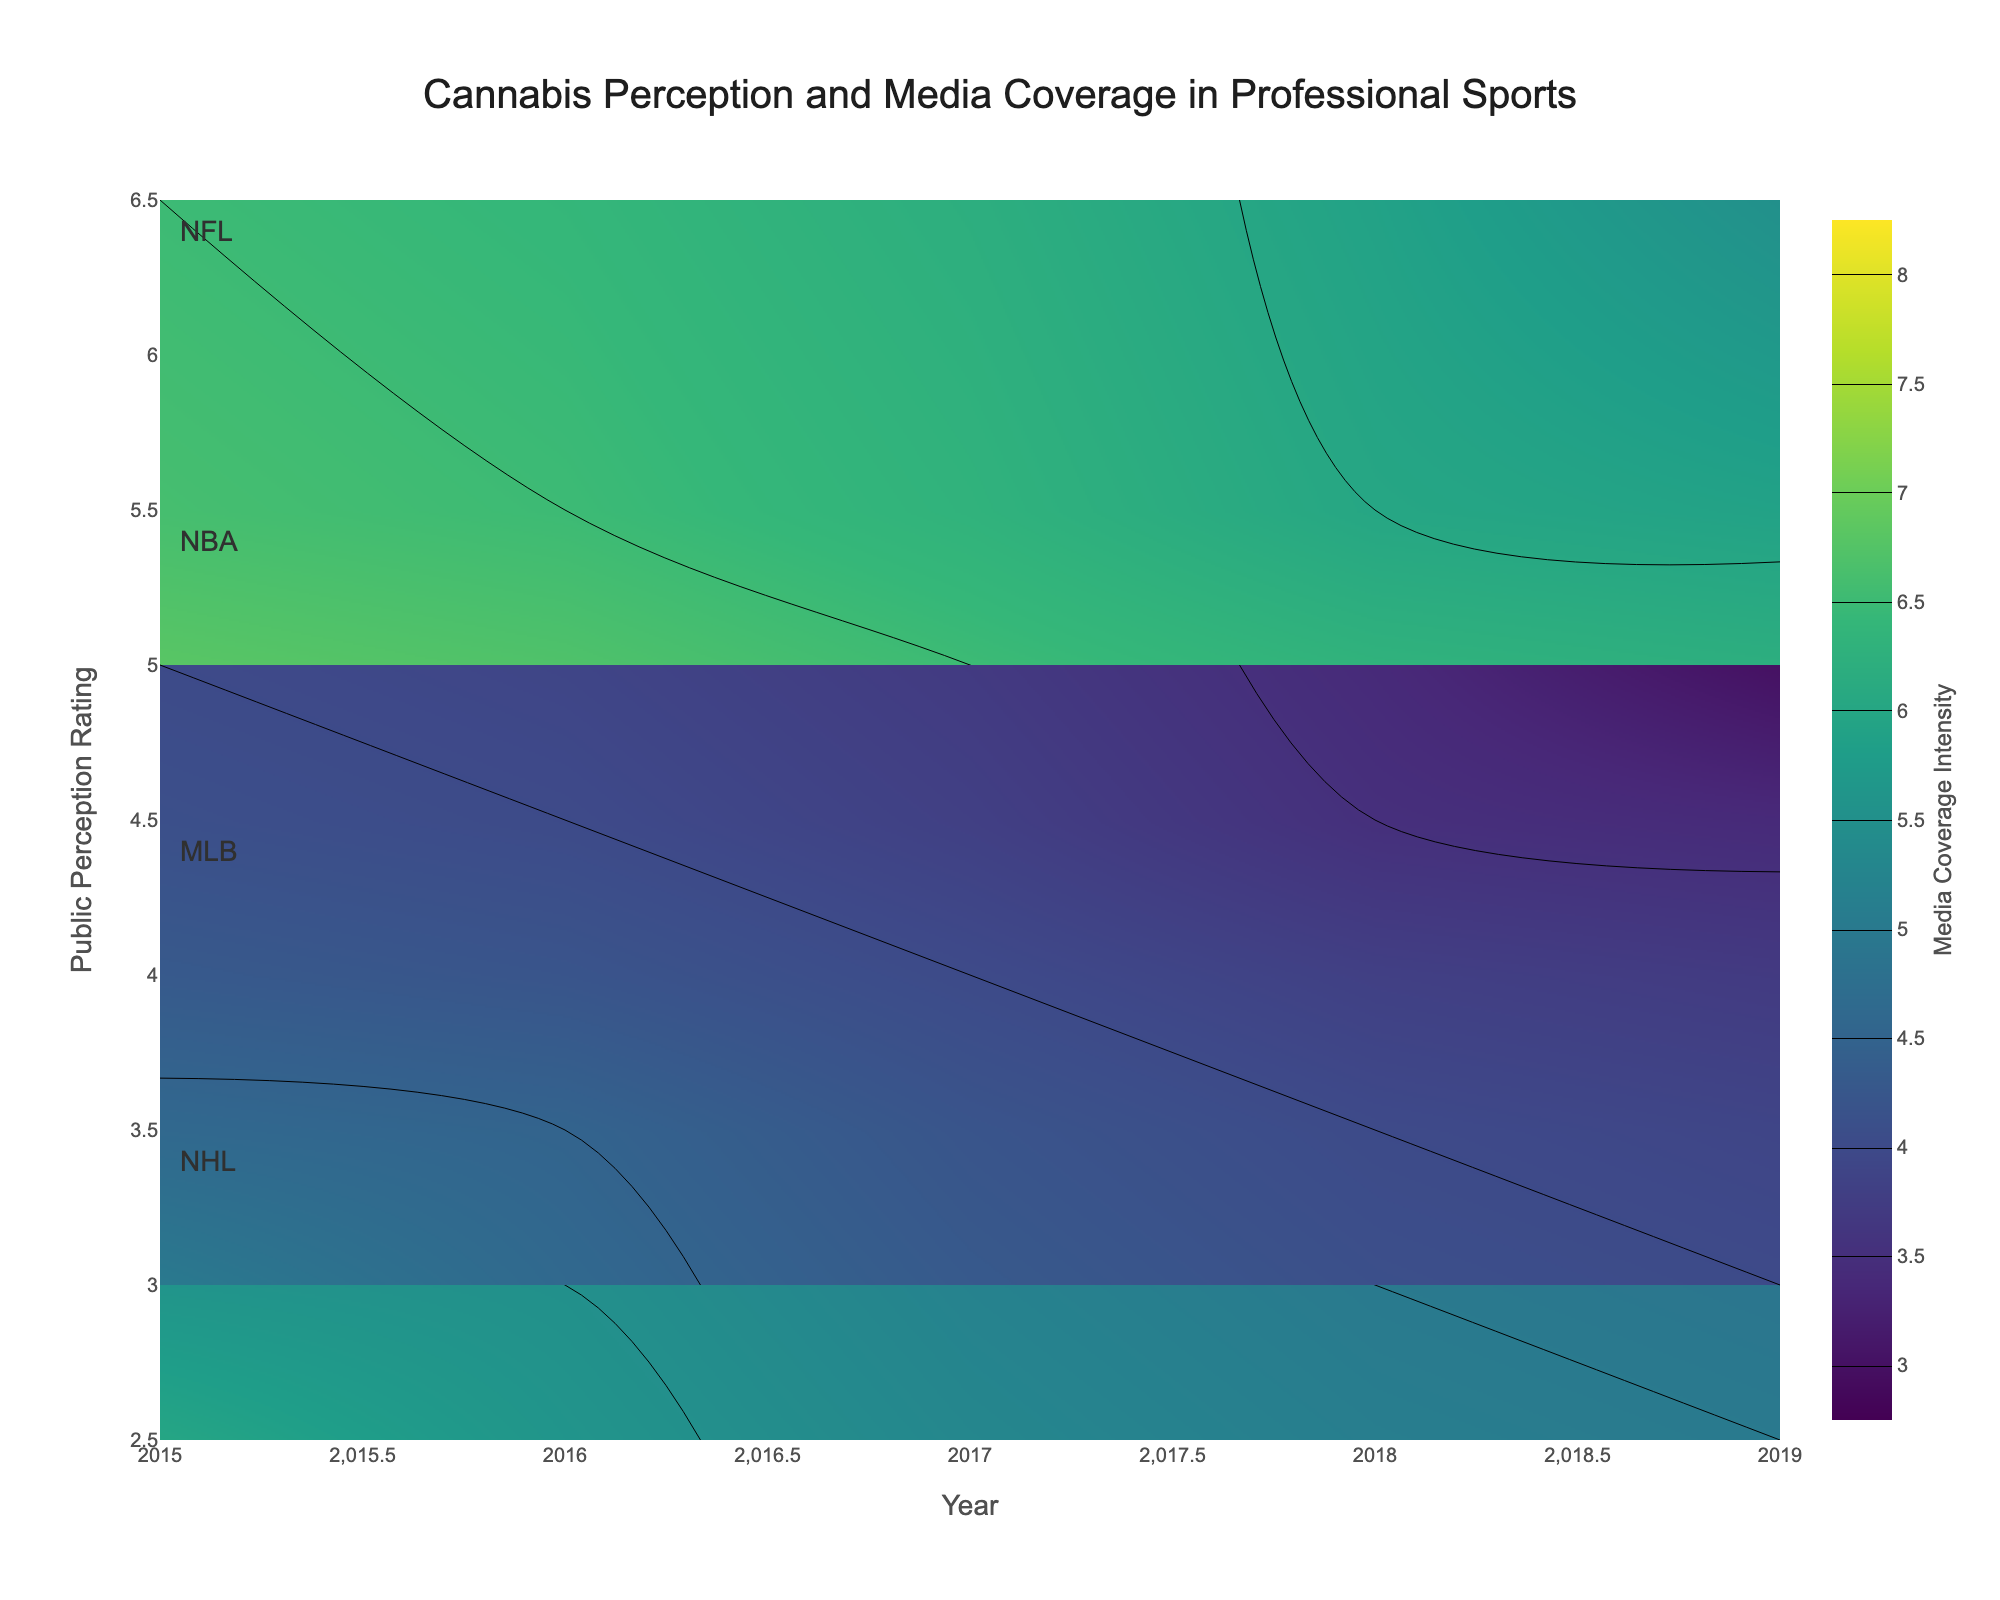What is the title of the figure? The title is typically placed at the top of the figure. It usually summarizes what the entire figure is representing.
Answer: Cannabis Perception and Media Coverage in Professional Sports Which sport had the highest public perception rating in 2019? This can be identified by looking at the highest point on the y-axis labeled 'Public Perception Rating' in the year 2019.
Answer: NBA What is the general trend in media coverage intensity for NFL from 2015 to 2019? Look at how the contour lines or color changes for the NFL from 2015 to 2019. Media coverage intensity is shown with a color scale.
Answer: Decreasing Compare the public perception ratings between MLB and NHL in 2017. Which one is higher? Check the heights of the points in 2017 for MLB and NHL on the y-axis representing 'Public Perception Rating'.
Answer: NHL Which sport experienced the most significant increase in public perception rating from 2015 to 2019? Calculate the difference between the starting (2015) and ending (2019) points in public perception rating for each sport and compare the differences.
Answer: NBA By how much did the public perception rating for NHL change from 2015 to 2018? Calculate the difference between the public perception rating in 2015 and 2018 for NHL by subtracting the 2015 value from the 2018 value.
Answer: 1.5 Around which year did the media coverage intensity for NBA start declining? Observe the point where the color representing the media coverage intensity starts decreasing for NBA on the color scale.
Answer: 2016 What is the median public perception rating of all sports in 2017? List the public perception ratings for all sports in 2017 and find the middle value when they are in order.
Answer: 4.5 Which sport had the most stable media coverage intensity from 2015 to 2019? Look for the sport whose contour lines or shading in media coverage intensity don't change much over time.
Answer: MLB 